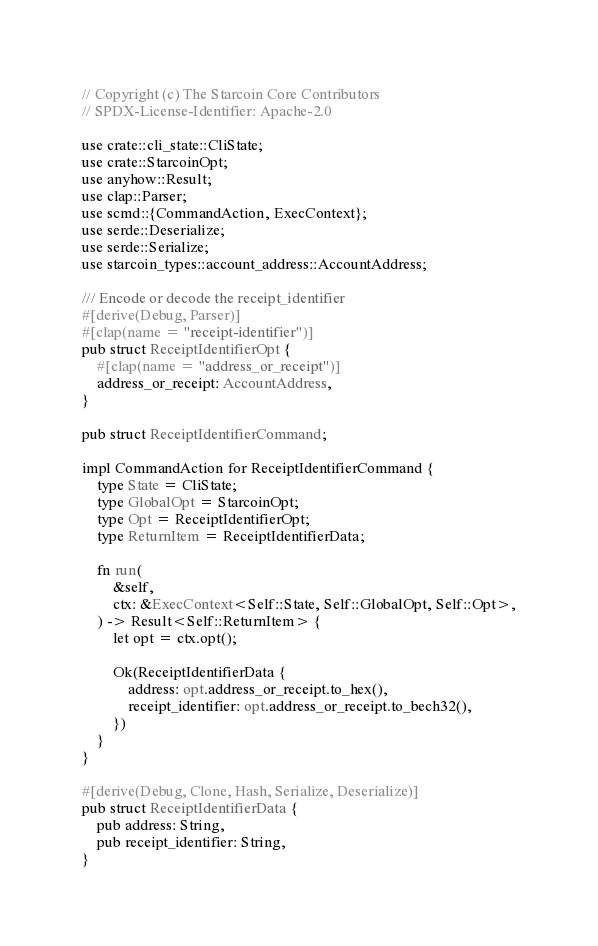<code> <loc_0><loc_0><loc_500><loc_500><_Rust_>// Copyright (c) The Starcoin Core Contributors
// SPDX-License-Identifier: Apache-2.0

use crate::cli_state::CliState;
use crate::StarcoinOpt;
use anyhow::Result;
use clap::Parser;
use scmd::{CommandAction, ExecContext};
use serde::Deserialize;
use serde::Serialize;
use starcoin_types::account_address::AccountAddress;

/// Encode or decode the receipt_identifier
#[derive(Debug, Parser)]
#[clap(name = "receipt-identifier")]
pub struct ReceiptIdentifierOpt {
    #[clap(name = "address_or_receipt")]
    address_or_receipt: AccountAddress,
}

pub struct ReceiptIdentifierCommand;

impl CommandAction for ReceiptIdentifierCommand {
    type State = CliState;
    type GlobalOpt = StarcoinOpt;
    type Opt = ReceiptIdentifierOpt;
    type ReturnItem = ReceiptIdentifierData;

    fn run(
        &self,
        ctx: &ExecContext<Self::State, Self::GlobalOpt, Self::Opt>,
    ) -> Result<Self::ReturnItem> {
        let opt = ctx.opt();

        Ok(ReceiptIdentifierData {
            address: opt.address_or_receipt.to_hex(),
            receipt_identifier: opt.address_or_receipt.to_bech32(),
        })
    }
}

#[derive(Debug, Clone, Hash, Serialize, Deserialize)]
pub struct ReceiptIdentifierData {
    pub address: String,
    pub receipt_identifier: String,
}
</code> 